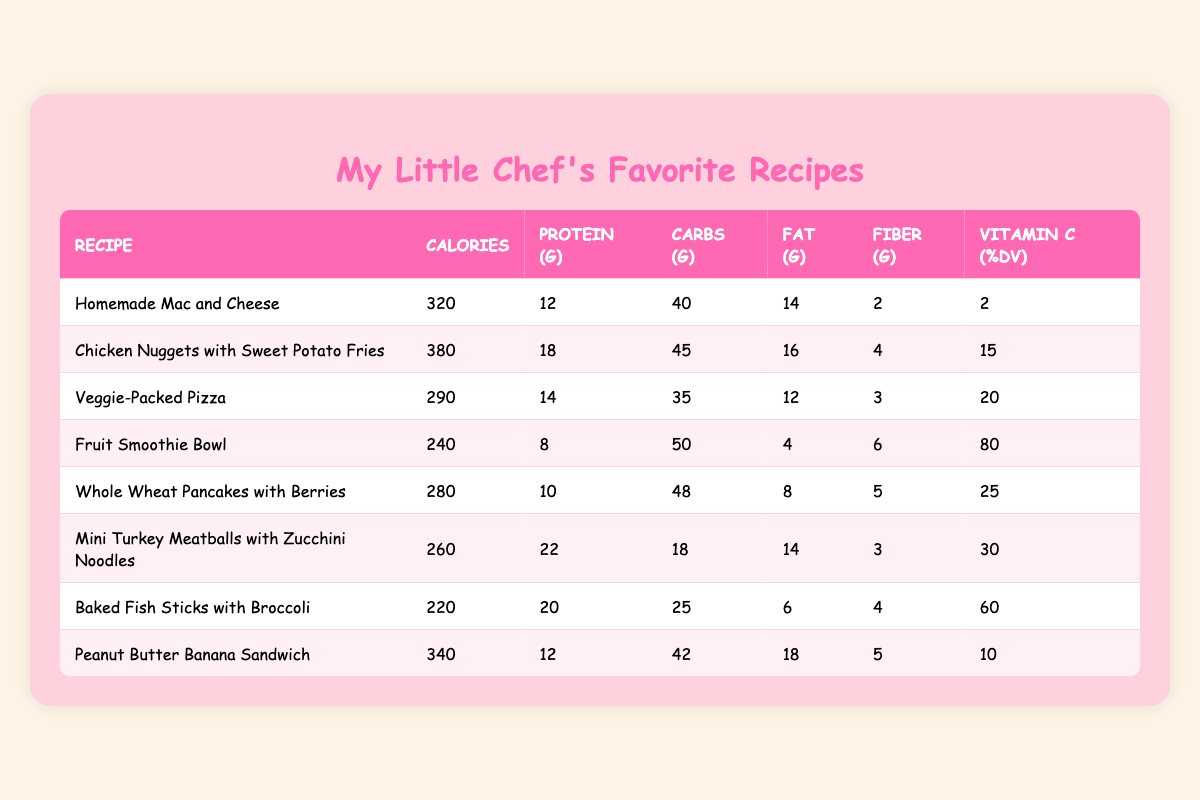What is the calorie count of Veggie-Packed Pizza? The calorie count for Veggie-Packed Pizza is found in the "Calories" column under its corresponding row in the table. It shows 290 calories.
Answer: 290 How much protein is in Homemade Mac and Cheese? The protein content is listed in the "Protein (g)" column next to the Homemade Mac and Cheese row. The value is 12 grams.
Answer: 12 Which recipe has the highest Vitamin C content? To find the highest Vitamin C percentage, examine the "Vitamin C (%DV)" column for all recipes. Fruit Smoothie Bowl has the highest at 80% DV.
Answer: Fruit Smoothie Bowl What is the total amount of carbs in Chicken Nuggets with Sweet Potato Fries and Mini Turkey Meatballs with Zucchini Noodles? First, identify the carbs for each dish: Chicken Nuggets has 45 grams and Mini Turkey Meatballs has 18 grams. Summing these values gives 63 grams: 45 + 18 = 63.
Answer: 63 Is the fat content in Baked Fish Sticks with Broccoli less than 10 grams? Check the "Fat (g)" column for Baked Fish Sticks with Broccoli, which shows 6 grams. Since 6 grams is less than 10, the statement is true.
Answer: Yes What is the average fiber content across all the recipes? First, we sum the fiber content of each recipe: 2 + 4 + 3 + 6 + 5 + 3 + 4 + 5 = 32 grams total. There are 8 recipes, so the average is 32 divided by 8, which equals 4 grams.
Answer: 4 Which recipe has the lowest total calories? To find the lowest calorie recipe, we review the "Calories" column. Baked Fish Sticks with Broccoli has the lowest at 220 calories.
Answer: Baked Fish Sticks with Broccoli Are there any recipes with more than 20 grams of protein? Check the "Protein (g)" column for all recipes. Mini Turkey Meatballs with Zucchini Noodles has 22 grams and Baked Fish Sticks with Broccoli has 20 grams, making them both valid answers. Since more than one recipe meets the criteria, the answer is yes.
Answer: Yes What is the difference in calories between Chicken Nuggets with Sweet Potato Fries and Homemade Mac and Cheese? First, find the calorie counts: Chicken Nuggets (380) and Homemade Mac and Cheese (320). The difference is 380 - 320 = 60 calories.
Answer: 60 